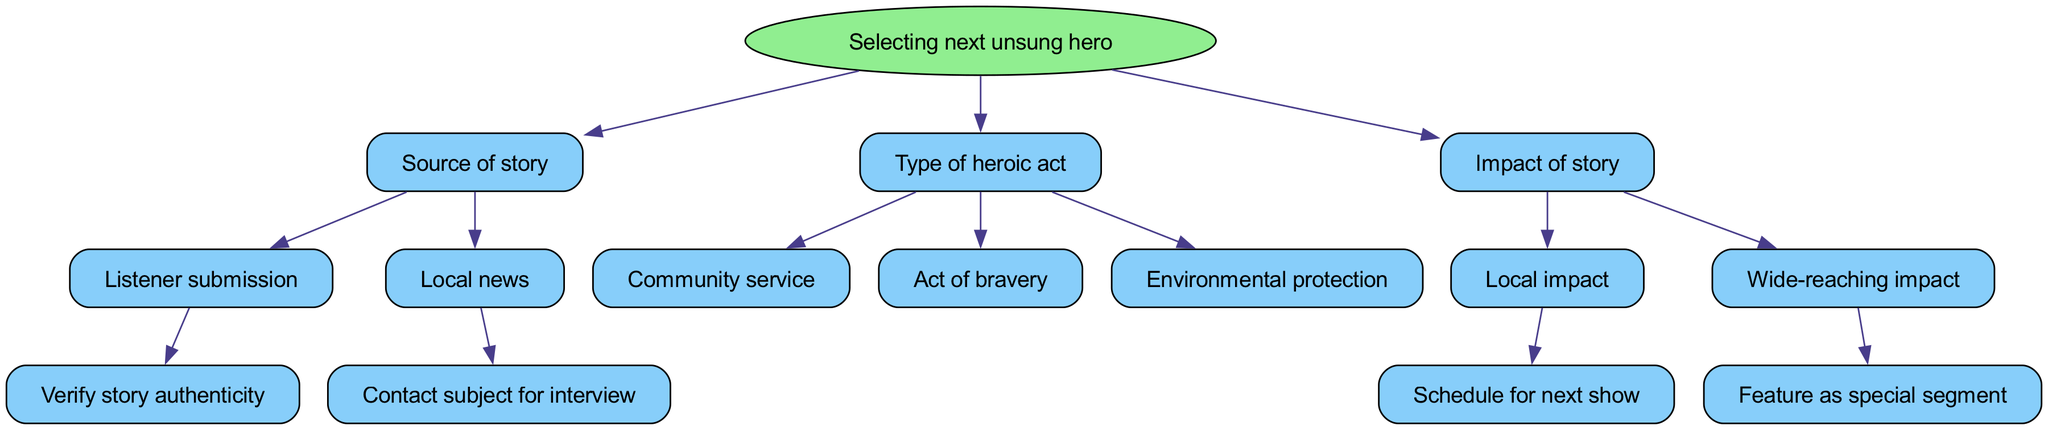What is the root of the diagram? The root of the diagram is the main decision point or question, which in this case is "Selecting next unsung hero".
Answer: Selecting next unsung hero How many types of sources of stories are there? Under the "Source of story" node, there are two types: "Listener submission" and "Local news". Thus, the total count is 2.
Answer: 2 What should be done after a listener submission is received? After receiving a listener submission, the next step is to "Verify story authenticity".
Answer: Verify story authenticity What impacts the scheduling for the next show? "Local impact" is the factor that influences scheduling for the next show in this diagram.
Answer: Local impact If a story has a wide-reaching impact, what action should be taken? In the case of a "Wide-reaching impact", the action to be taken according to the diagram is to "Feature as special segment".
Answer: Feature as special segment What type of heroic act is not explicitly mentioned under the "Type of heroic act" section? The "Type of heroic act" section includes community service, act of bravery, and environmental protection, while no mention is made of individual acts or achievements.
Answer: Individual acts How many children does the "Impact of story" node have? The "Impact of story" node has two children: "Local impact" and "Wide-reaching impact," making the total count 2.
Answer: 2 What action follows after determining a story has a community service type? The "Type of heroic act" allows for multiple types; however, community service does not directly lead to a subsequent action in the diagram as it is a standalone classification.
Answer: N/A What is the method used to feature stories from local news? The method indicated after identifying a story from local news is to "Contact subject for interview".
Answer: Contact subject for interview 